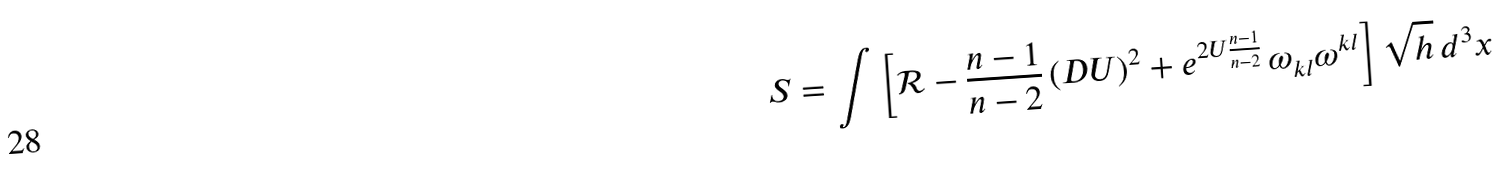Convert formula to latex. <formula><loc_0><loc_0><loc_500><loc_500>S = \int \left [ \mathcal { R } - \frac { n - 1 } { n - 2 } \, ( D U ) ^ { 2 } + e ^ { 2 U \frac { n - 1 } { n - 2 } } \, \omega _ { k l } \omega ^ { k l } \right ] \sqrt { h } \, d ^ { 3 } x</formula> 